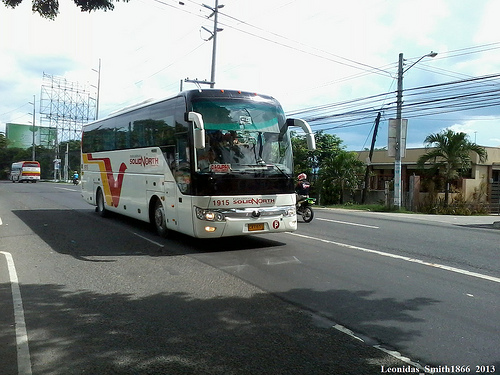Please provide a short description for this region: [0.83, 0.37, 0.96, 0.57]. A palm tree located at the corner of a street. 